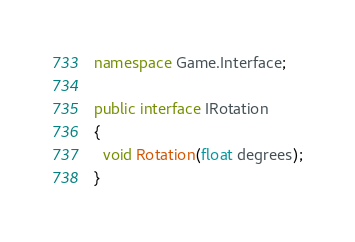Convert code to text. <code><loc_0><loc_0><loc_500><loc_500><_C#_>namespace Game.Interface;

public interface IRotation
{
  void Rotation(float degrees);
}</code> 